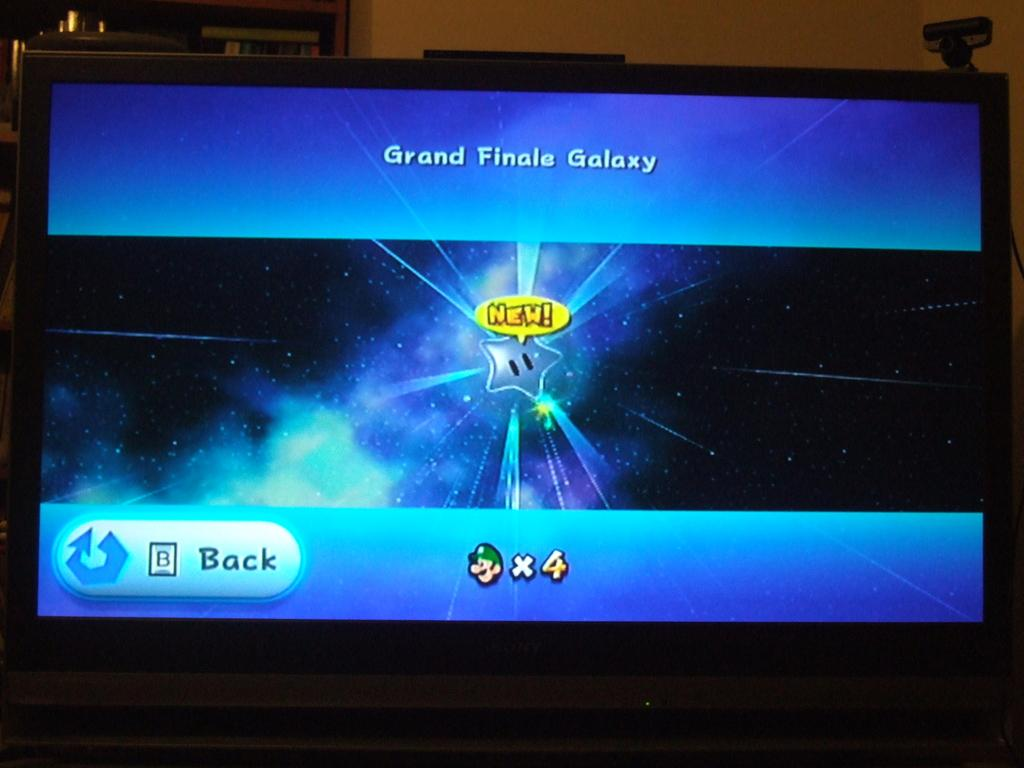<image>
Offer a succinct explanation of the picture presented. The screen of a game where you are at the Grand Finale Galaxy 